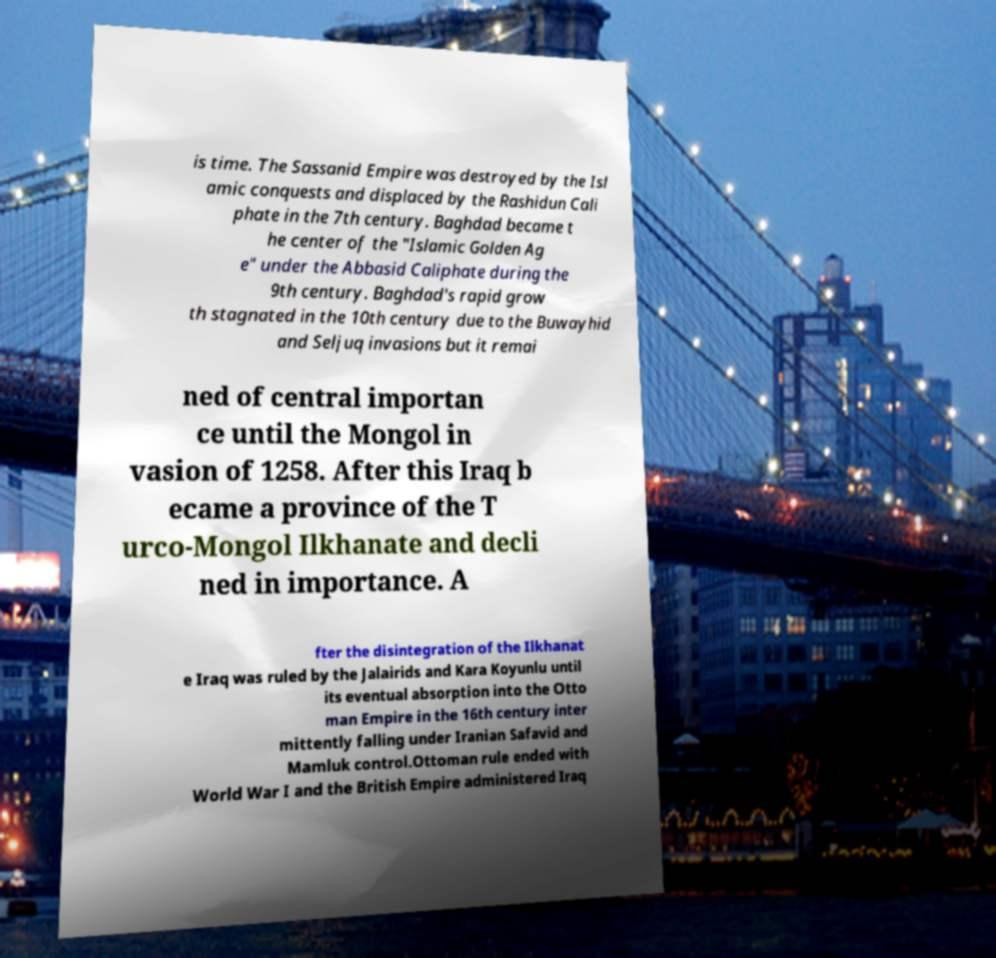Can you read and provide the text displayed in the image?This photo seems to have some interesting text. Can you extract and type it out for me? is time. The Sassanid Empire was destroyed by the Isl amic conquests and displaced by the Rashidun Cali phate in the 7th century. Baghdad became t he center of the "Islamic Golden Ag e" under the Abbasid Caliphate during the 9th century. Baghdad's rapid grow th stagnated in the 10th century due to the Buwayhid and Seljuq invasions but it remai ned of central importan ce until the Mongol in vasion of 1258. After this Iraq b ecame a province of the T urco-Mongol Ilkhanate and decli ned in importance. A fter the disintegration of the Ilkhanat e Iraq was ruled by the Jalairids and Kara Koyunlu until its eventual absorption into the Otto man Empire in the 16th century inter mittently falling under Iranian Safavid and Mamluk control.Ottoman rule ended with World War I and the British Empire administered Iraq 